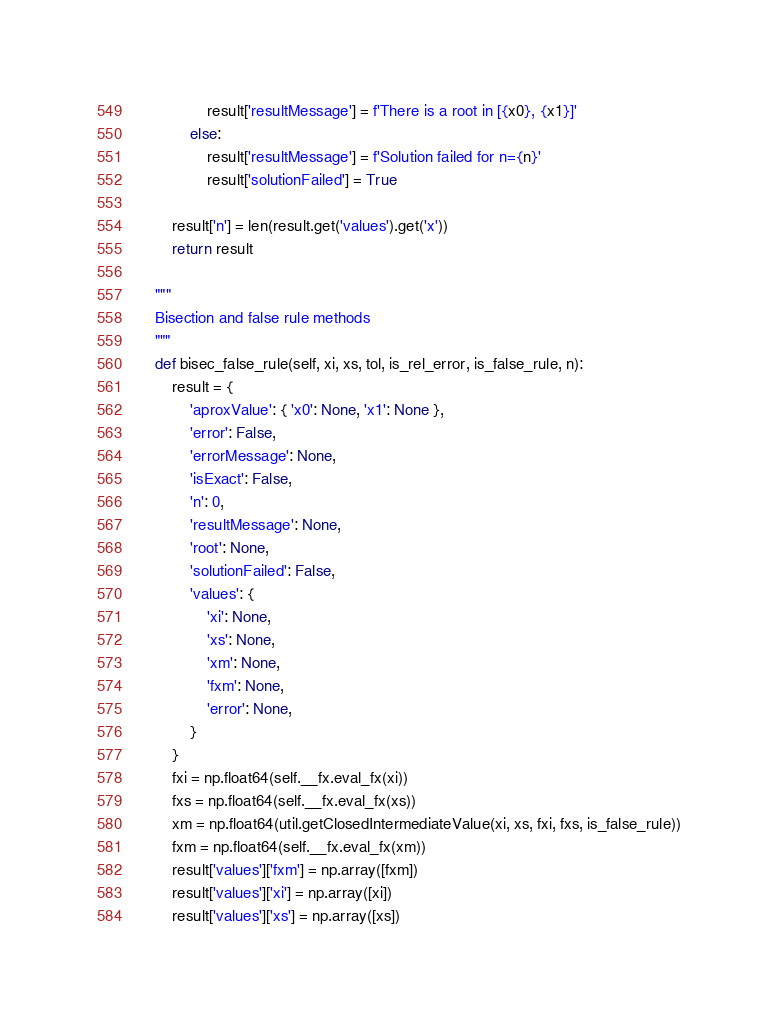Convert code to text. <code><loc_0><loc_0><loc_500><loc_500><_Python_>                result['resultMessage'] = f'There is a root in [{x0}, {x1}]'
            else:
                result['resultMessage'] = f'Solution failed for n={n}'
                result['solutionFailed'] = True

        result['n'] = len(result.get('values').get('x'))
        return result

    """
    Bisection and false rule methods
    """
    def bisec_false_rule(self, xi, xs, tol, is_rel_error, is_false_rule, n):
        result = {
            'aproxValue': { 'x0': None, 'x1': None },
            'error': False,
            'errorMessage': None,
            'isExact': False,
            'n': 0,
            'resultMessage': None,
            'root': None,
            'solutionFailed': False,
            'values': {
                'xi': None,
                'xs': None,
                'xm': None,
                'fxm': None,
                'error': None,
            }
        }
        fxi = np.float64(self.__fx.eval_fx(xi))
        fxs = np.float64(self.__fx.eval_fx(xs))
        xm = np.float64(util.getClosedIntermediateValue(xi, xs, fxi, fxs, is_false_rule))
        fxm = np.float64(self.__fx.eval_fx(xm))
        result['values']['fxm'] = np.array([fxm])
        result['values']['xi'] = np.array([xi])
        result['values']['xs'] = np.array([xs])</code> 